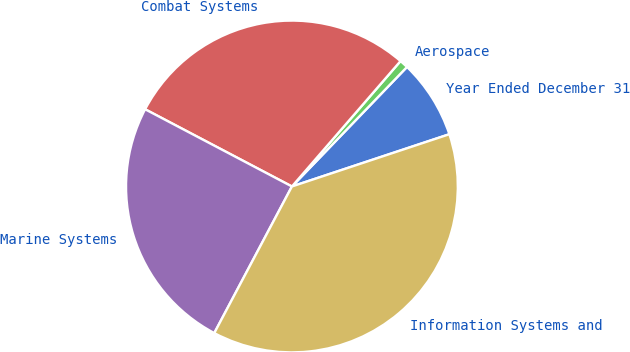Convert chart to OTSL. <chart><loc_0><loc_0><loc_500><loc_500><pie_chart><fcel>Year Ended December 31<fcel>Aerospace<fcel>Combat Systems<fcel>Marine Systems<fcel>Information Systems and<nl><fcel>7.7%<fcel>0.84%<fcel>28.65%<fcel>24.95%<fcel>37.85%<nl></chart> 